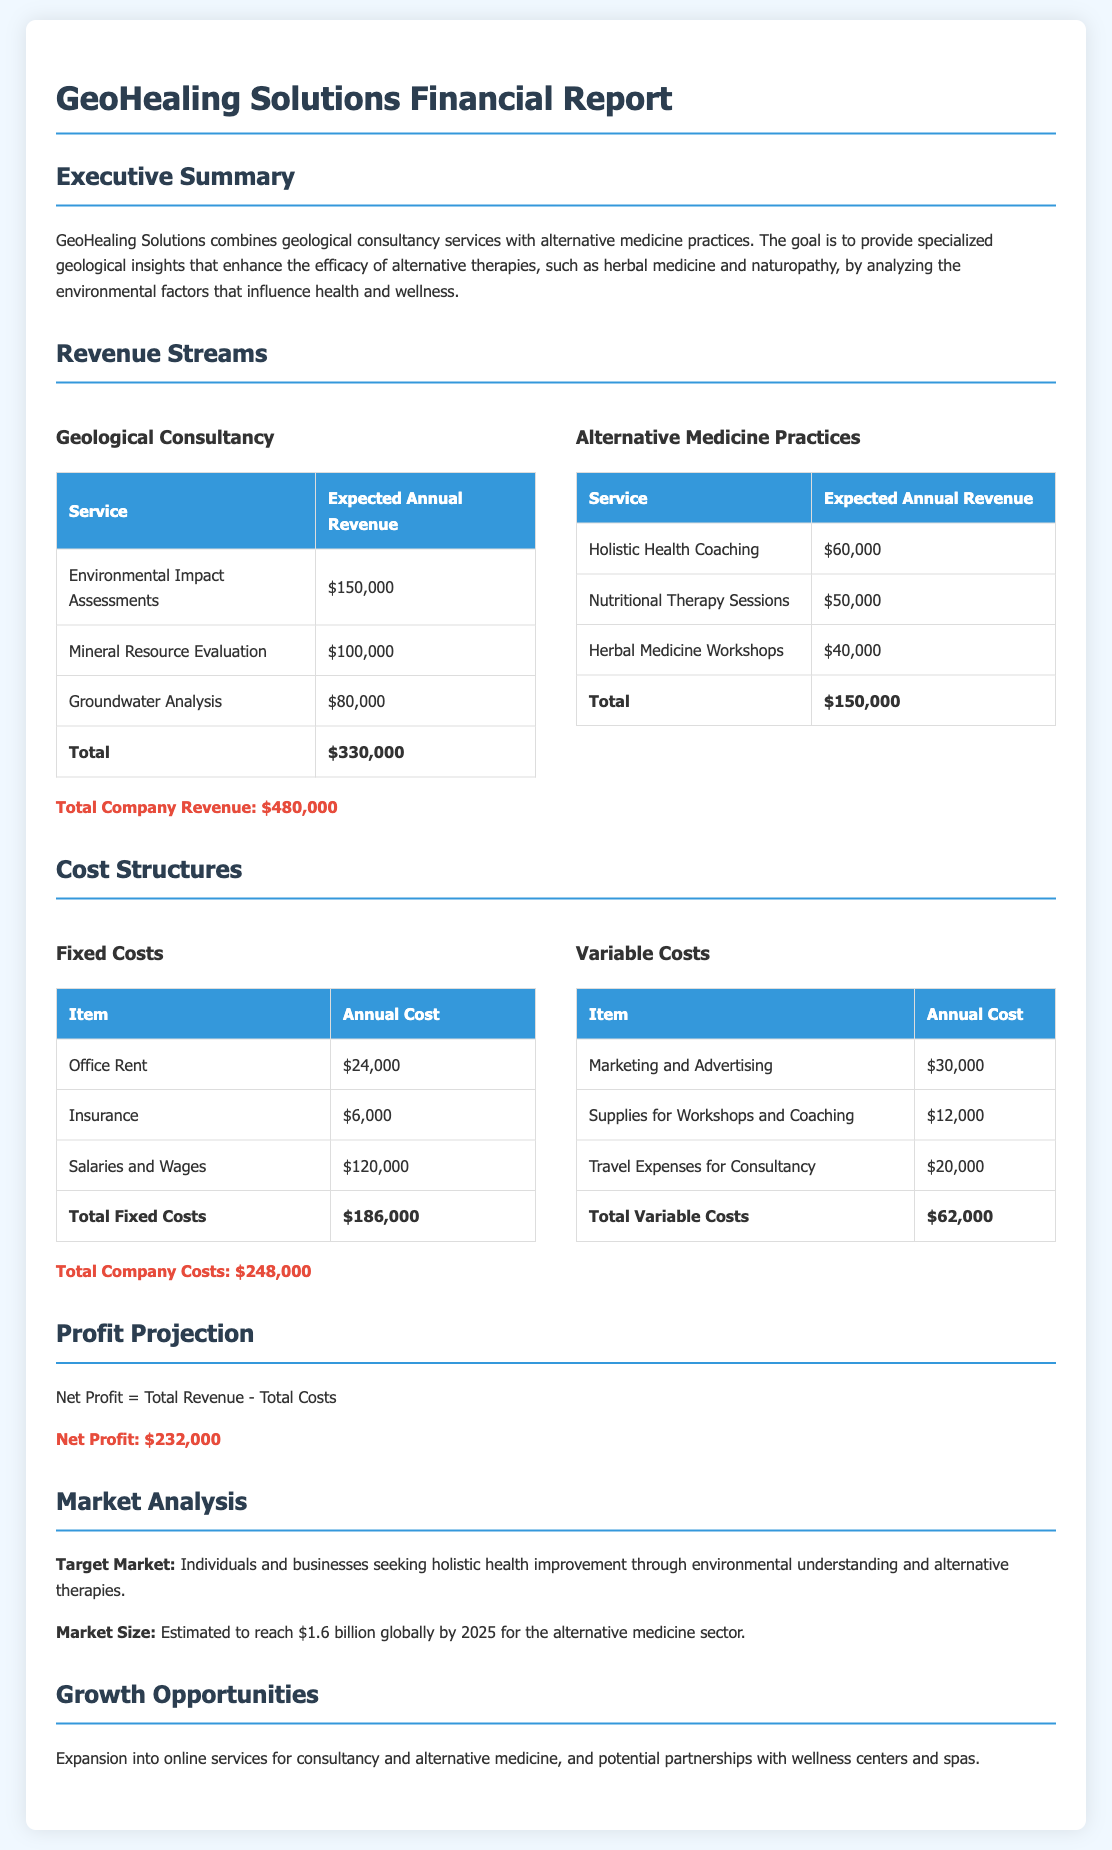What is the total expected annual revenue from geological consultancy? The document lists the expected annual revenues for various geological consultancy services, which total $330,000.
Answer: $330,000 What is the expected annual revenue from Nutritional Therapy Sessions? The document specifies the expected annual revenue for Nutritional Therapy Sessions as $50,000.
Answer: $50,000 What are the total fixed costs outlined in the report? The total fixed costs are calculated by adding up the listed fixed costs, which sum to $186,000.
Answer: $186,000 What is the net profit projected for GeoHealing Solutions? The document states that the net profit is obtained by subtracting total costs from total revenue, resulting in $232,000.
Answer: $232,000 What is the total expected annual revenue from alternative medicine practices? The document outlines expected annual revenues for alternative medicine services, totaling $150,000.
Answer: $150,000 What is the total company cost as stated in the report? The total company costs are derived from adding fixed and variable costs, which equals $248,000.
Answer: $248,000 What market size is estimated for the alternative medicine sector by 2025? The document indicates that the estimated market size for the alternative medicine sector is projected to reach $1.6 billion.
Answer: $1.6 billion What are the total variable costs mentioned in the report? The total variable costs are calculated as $62,000 from the listed items in the document.
Answer: $62,000 What type of services does GeoHealing Solutions provide? The report describes the services provided as geological consultancy and alternative medicine practices.
Answer: Geological consultancy and alternative medicine practices 